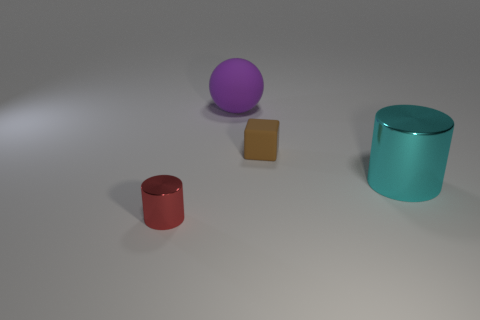What can you tell me about the lighting in this scene? The scene is evenly lit with what appears to be a diffuse light source, creating soft shadows for each object. The light direction is not immediately apparent, indicating the source may be positioned above, casting a gentle illumination across the entire scene. 